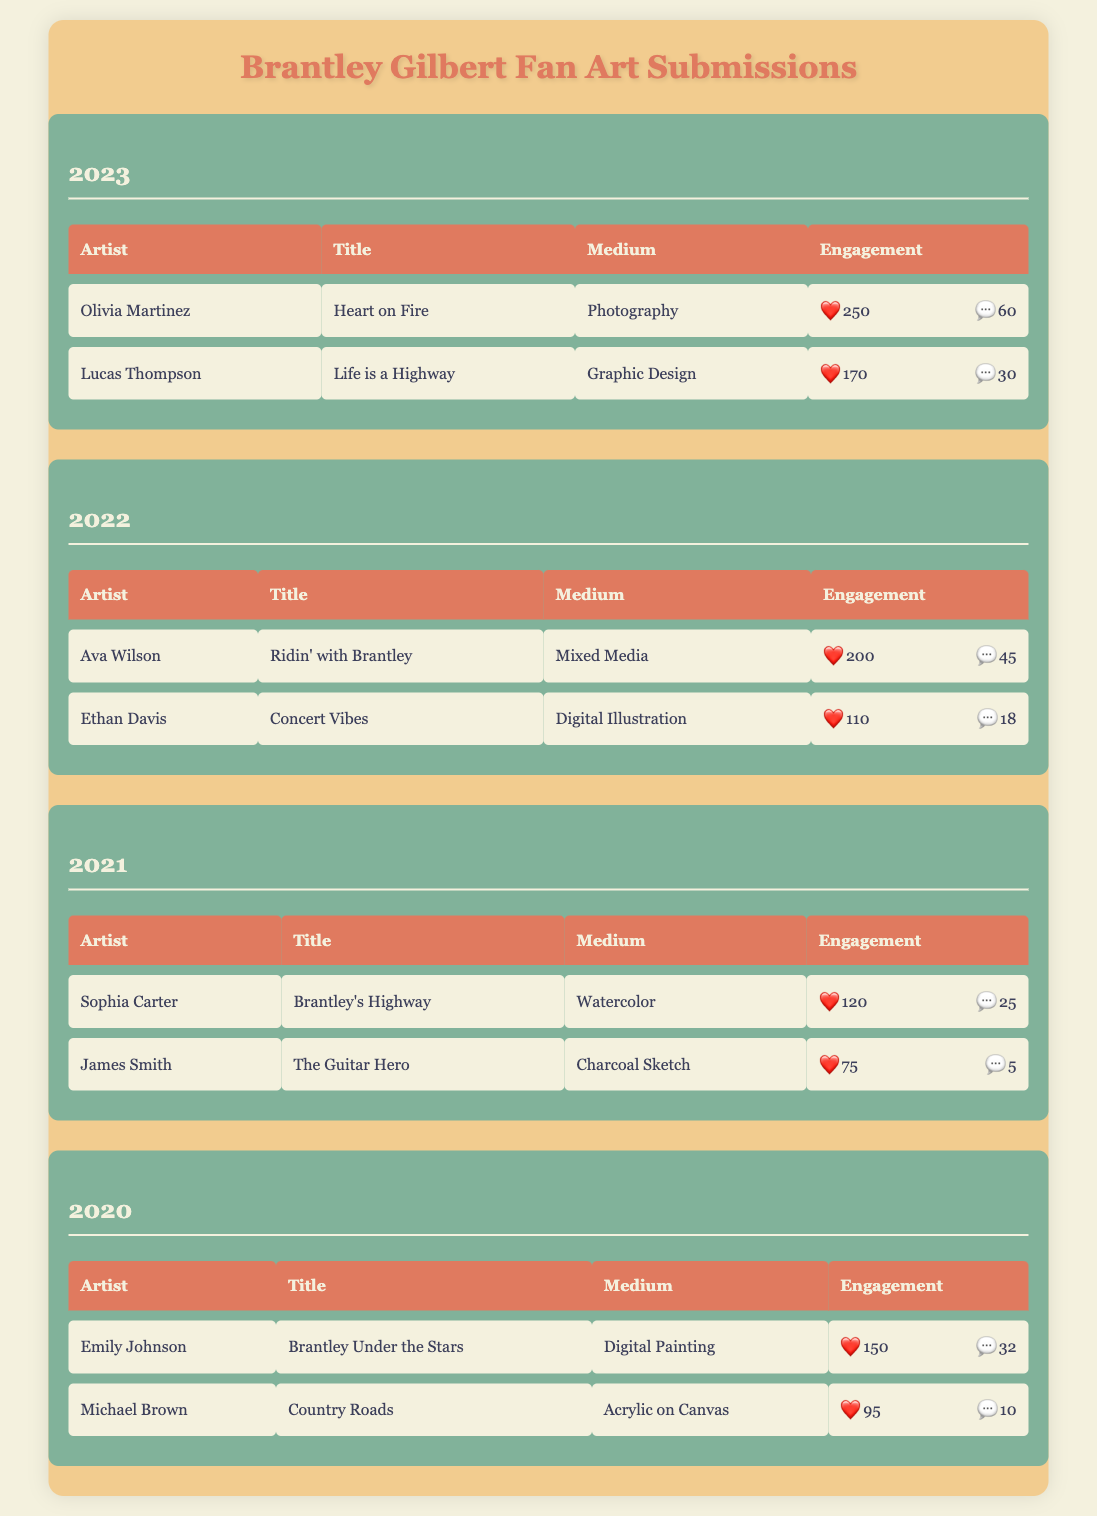What was the title of the fan art submission by Ava Wilson in 2022? According to the table, Ava Wilson's submission in 2022 is titled "Ridin’ with Brantley".
Answer: Ridin’ with Brantley Which artist received the highest number of likes in 2023? From the table, I can see that Olivia Martinez has 250 likes, which is higher than Lucas Thompson's 170 likes. Thus, Olivia Martinez received the highest number of likes in 2023.
Answer: Olivia Martinez What is the total number of comments for fan art submissions in 2021? For 2021, I will add the comments: Sophia Carter has 25 comments, and James Smith has 5 comments. So, 25 + 5 = 30 comments in total for that year.
Answer: 30 Did Michael Brown receive more likes than James Smith in 2021? Yes, Michael Brown's submission has 95 likes, while James Smith has 75 likes. Thus, the statement is true.
Answer: Yes What is the average number of likes for fan art submissions in 2022? To find the average, I will add the likes: Ava Wilson (200) + Ethan Davis (110) = 310. There are 2 submissions, so the average is 310 / 2 = 155.
Answer: 155 Which medium was used for the artwork titled "The Guitar Hero"? According to the table, "The Guitar Hero" was created using a charcoal sketch as the medium.
Answer: Charcoal Sketch What is the difference in the number of likes between "Heart on Fire" and "Ridin’ with Brantley"? "Heart on Fire" has 250 likes, while "Ridin’ with Brantley" has 200 likes. The difference is 250 - 200 = 50 likes.
Answer: 50 Is there a submission in 2020 that received more than 100 likes? Yes, Emily Johnson's submission "Brantley Under the Stars" received 150 likes, which is more than 100.
Answer: Yes What was the least liked submission in 2021? In 2021, James Smith's "The Guitar Hero" received the least likes with 75 likes compared to Sophia Carter's 120 likes.
Answer: The Guitar Hero 